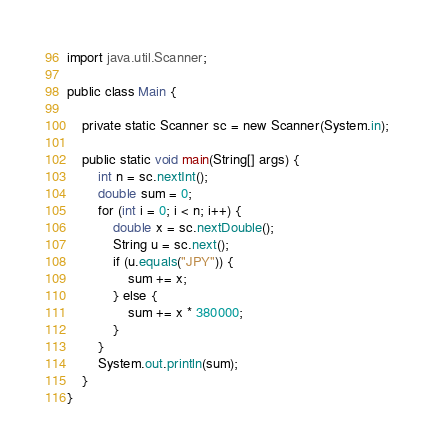<code> <loc_0><loc_0><loc_500><loc_500><_Java_>import java.util.Scanner;

public class Main {

	private static Scanner sc = new Scanner(System.in);

	public static void main(String[] args) {
		int n = sc.nextInt();
		double sum = 0;
		for (int i = 0; i < n; i++) {
			double x = sc.nextDouble();
			String u = sc.next();
			if (u.equals("JPY")) {
				sum += x;
			} else {
				sum += x * 380000;
			}
		}
		System.out.println(sum);
	}
}</code> 